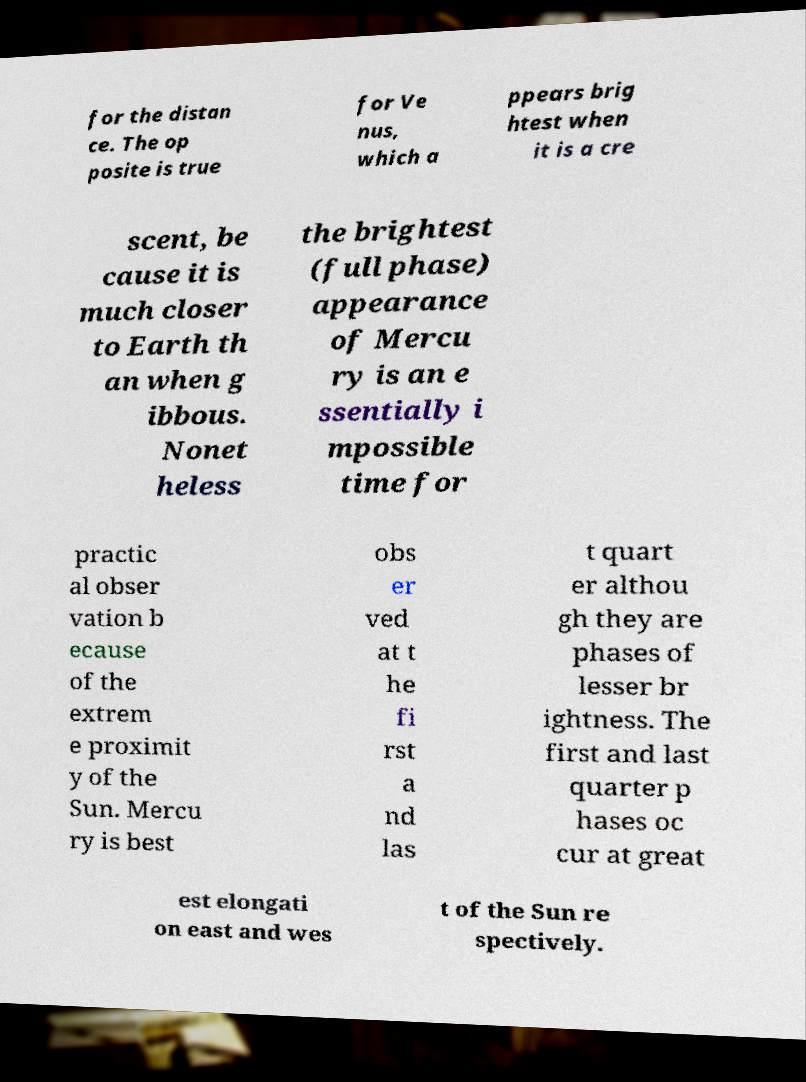Please identify and transcribe the text found in this image. for the distan ce. The op posite is true for Ve nus, which a ppears brig htest when it is a cre scent, be cause it is much closer to Earth th an when g ibbous. Nonet heless the brightest (full phase) appearance of Mercu ry is an e ssentially i mpossible time for practic al obser vation b ecause of the extrem e proximit y of the Sun. Mercu ry is best obs er ved at t he fi rst a nd las t quart er althou gh they are phases of lesser br ightness. The first and last quarter p hases oc cur at great est elongati on east and wes t of the Sun re spectively. 